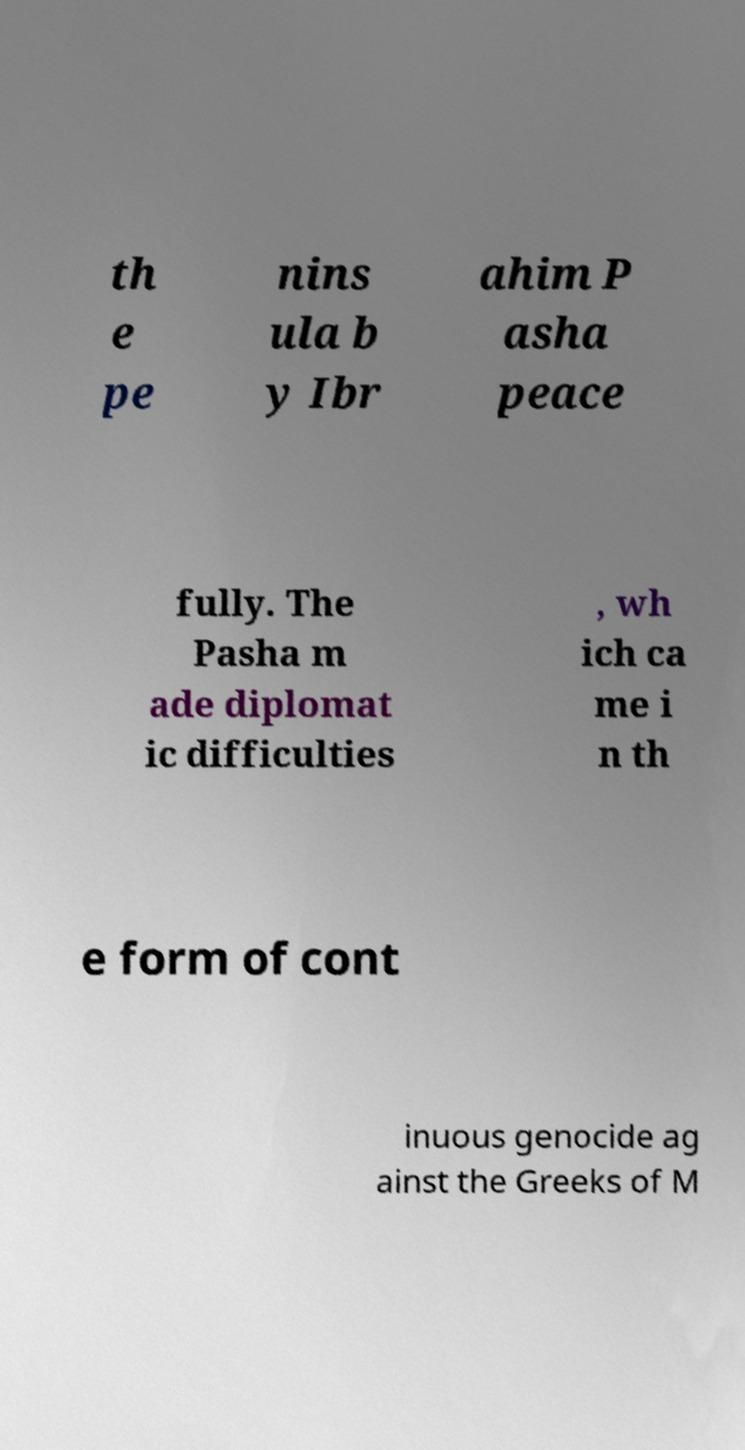There's text embedded in this image that I need extracted. Can you transcribe it verbatim? th e pe nins ula b y Ibr ahim P asha peace fully. The Pasha m ade diplomat ic difficulties , wh ich ca me i n th e form of cont inuous genocide ag ainst the Greeks of M 